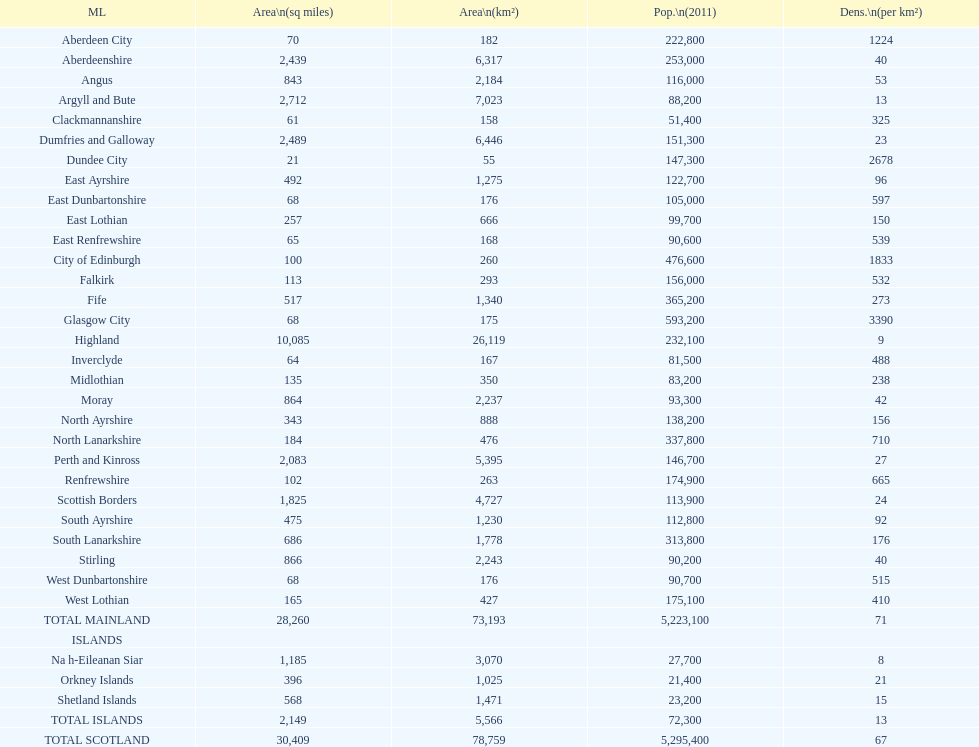What is the total area of east lothian, angus, and dundee city? 1121. 